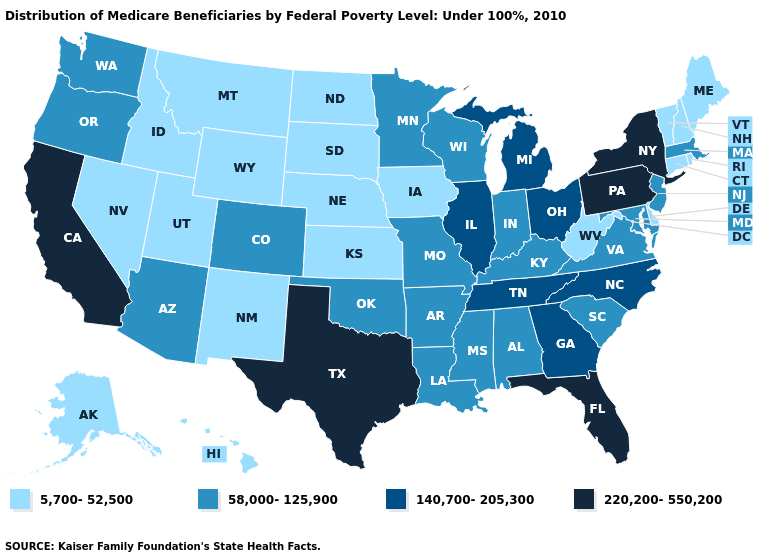What is the value of Colorado?
Answer briefly. 58,000-125,900. Among the states that border Kansas , which have the lowest value?
Keep it brief. Nebraska. Name the states that have a value in the range 58,000-125,900?
Give a very brief answer. Alabama, Arizona, Arkansas, Colorado, Indiana, Kentucky, Louisiana, Maryland, Massachusetts, Minnesota, Mississippi, Missouri, New Jersey, Oklahoma, Oregon, South Carolina, Virginia, Washington, Wisconsin. What is the value of Louisiana?
Concise answer only. 58,000-125,900. What is the highest value in the South ?
Short answer required. 220,200-550,200. How many symbols are there in the legend?
Write a very short answer. 4. Name the states that have a value in the range 220,200-550,200?
Write a very short answer. California, Florida, New York, Pennsylvania, Texas. Which states have the highest value in the USA?
Answer briefly. California, Florida, New York, Pennsylvania, Texas. What is the lowest value in the MidWest?
Write a very short answer. 5,700-52,500. What is the value of Idaho?
Quick response, please. 5,700-52,500. Name the states that have a value in the range 220,200-550,200?
Be succinct. California, Florida, New York, Pennsylvania, Texas. Which states have the lowest value in the West?
Answer briefly. Alaska, Hawaii, Idaho, Montana, Nevada, New Mexico, Utah, Wyoming. Name the states that have a value in the range 220,200-550,200?
Concise answer only. California, Florida, New York, Pennsylvania, Texas. What is the highest value in the West ?
Answer briefly. 220,200-550,200. Among the states that border Minnesota , which have the highest value?
Concise answer only. Wisconsin. 